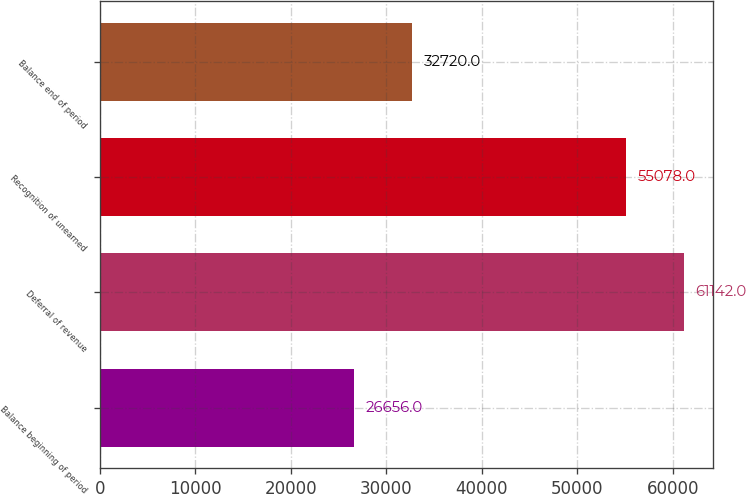Convert chart. <chart><loc_0><loc_0><loc_500><loc_500><bar_chart><fcel>Balance beginning of period<fcel>Deferral of revenue<fcel>Recognition of unearned<fcel>Balance end of period<nl><fcel>26656<fcel>61142<fcel>55078<fcel>32720<nl></chart> 